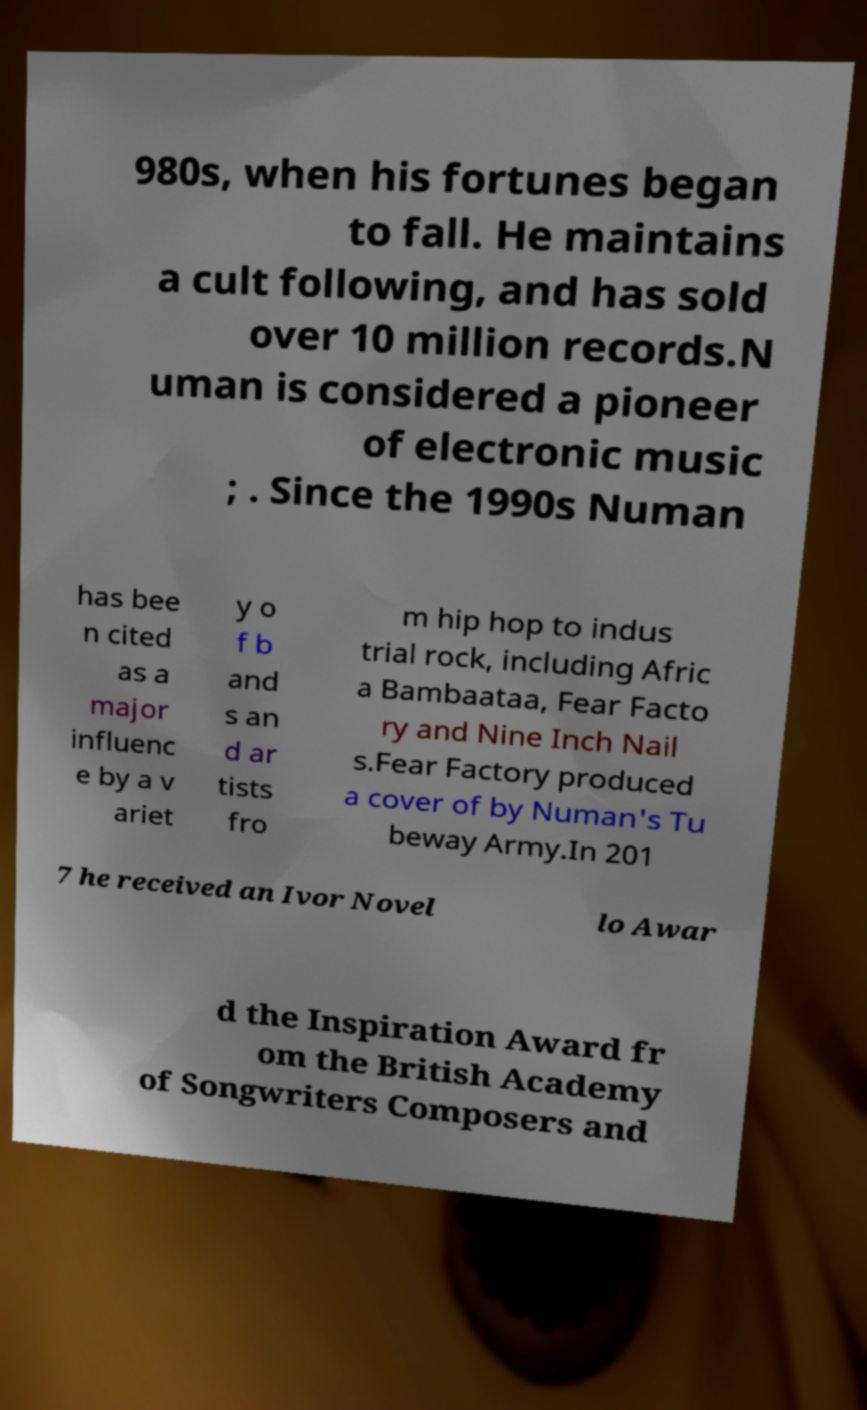Can you read and provide the text displayed in the image?This photo seems to have some interesting text. Can you extract and type it out for me? 980s, when his fortunes began to fall. He maintains a cult following, and has sold over 10 million records.N uman is considered a pioneer of electronic music ; . Since the 1990s Numan has bee n cited as a major influenc e by a v ariet y o f b and s an d ar tists fro m hip hop to indus trial rock, including Afric a Bambaataa, Fear Facto ry and Nine Inch Nail s.Fear Factory produced a cover of by Numan's Tu beway Army.In 201 7 he received an Ivor Novel lo Awar d the Inspiration Award fr om the British Academy of Songwriters Composers and 